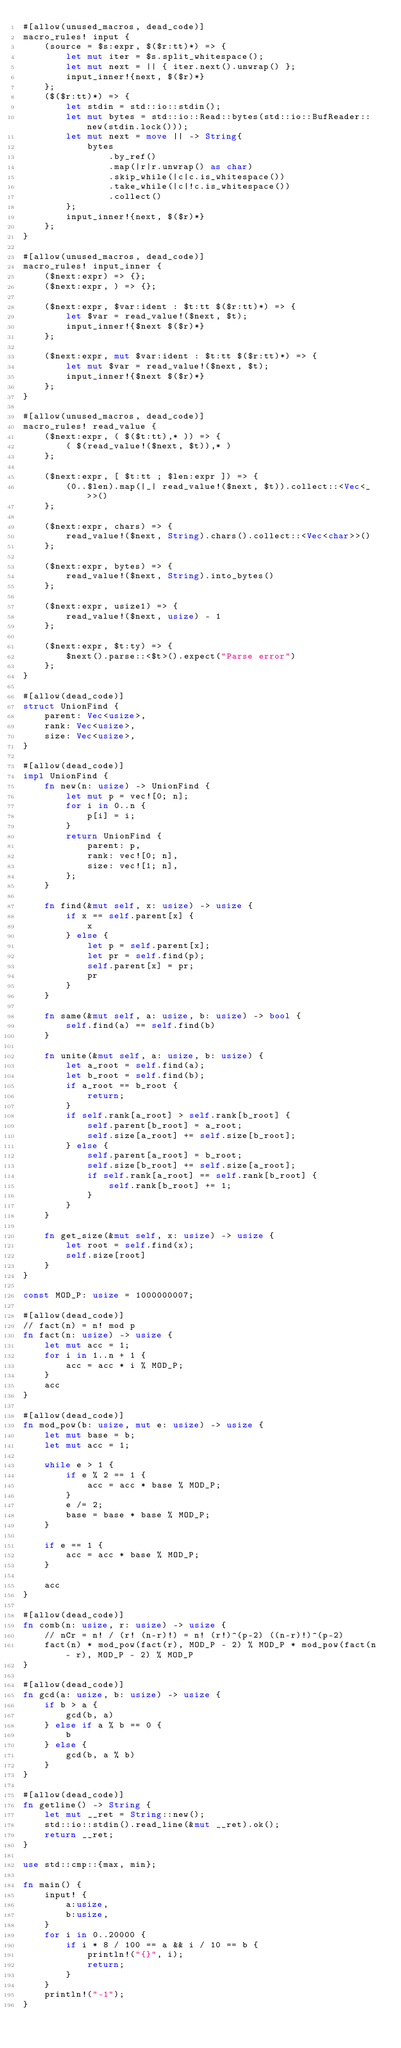Convert code to text. <code><loc_0><loc_0><loc_500><loc_500><_Rust_>#[allow(unused_macros, dead_code)]
macro_rules! input {
    (source = $s:expr, $($r:tt)*) => {
        let mut iter = $s.split_whitespace();
        let mut next = || { iter.next().unwrap() };
        input_inner!{next, $($r)*}
    };
    ($($r:tt)*) => {
        let stdin = std::io::stdin();
        let mut bytes = std::io::Read::bytes(std::io::BufReader::new(stdin.lock()));
        let mut next = move || -> String{
            bytes
                .by_ref()
                .map(|r|r.unwrap() as char)
                .skip_while(|c|c.is_whitespace())
                .take_while(|c|!c.is_whitespace())
                .collect()
        };
        input_inner!{next, $($r)*}
    };
}

#[allow(unused_macros, dead_code)]
macro_rules! input_inner {
    ($next:expr) => {};
    ($next:expr, ) => {};

    ($next:expr, $var:ident : $t:tt $($r:tt)*) => {
        let $var = read_value!($next, $t);
        input_inner!{$next $($r)*}
    };

    ($next:expr, mut $var:ident : $t:tt $($r:tt)*) => {
        let mut $var = read_value!($next, $t);
        input_inner!{$next $($r)*}
    };
}

#[allow(unused_macros, dead_code)]
macro_rules! read_value {
    ($next:expr, ( $($t:tt),* )) => {
        ( $(read_value!($next, $t)),* )
    };

    ($next:expr, [ $t:tt ; $len:expr ]) => {
        (0..$len).map(|_| read_value!($next, $t)).collect::<Vec<_>>()
    };

    ($next:expr, chars) => {
        read_value!($next, String).chars().collect::<Vec<char>>()
    };

    ($next:expr, bytes) => {
        read_value!($next, String).into_bytes()
    };

    ($next:expr, usize1) => {
        read_value!($next, usize) - 1
    };

    ($next:expr, $t:ty) => {
        $next().parse::<$t>().expect("Parse error")
    };
}

#[allow(dead_code)]
struct UnionFind {
    parent: Vec<usize>,
    rank: Vec<usize>,
    size: Vec<usize>,
}

#[allow(dead_code)]
impl UnionFind {
    fn new(n: usize) -> UnionFind {
        let mut p = vec![0; n];
        for i in 0..n {
            p[i] = i;
        }
        return UnionFind {
            parent: p,
            rank: vec![0; n],
            size: vec![1; n],
        };
    }

    fn find(&mut self, x: usize) -> usize {
        if x == self.parent[x] {
            x
        } else {
            let p = self.parent[x];
            let pr = self.find(p);
            self.parent[x] = pr;
            pr
        }
    }

    fn same(&mut self, a: usize, b: usize) -> bool {
        self.find(a) == self.find(b)
    }

    fn unite(&mut self, a: usize, b: usize) {
        let a_root = self.find(a);
        let b_root = self.find(b);
        if a_root == b_root {
            return;
        }
        if self.rank[a_root] > self.rank[b_root] {
            self.parent[b_root] = a_root;
            self.size[a_root] += self.size[b_root];
        } else {
            self.parent[a_root] = b_root;
            self.size[b_root] += self.size[a_root];
            if self.rank[a_root] == self.rank[b_root] {
                self.rank[b_root] += 1;
            }
        }
    }

    fn get_size(&mut self, x: usize) -> usize {
        let root = self.find(x);
        self.size[root]
    }
}

const MOD_P: usize = 1000000007;

#[allow(dead_code)]
// fact(n) = n! mod p
fn fact(n: usize) -> usize {
    let mut acc = 1;
    for i in 1..n + 1 {
        acc = acc * i % MOD_P;
    }
    acc
}

#[allow(dead_code)]
fn mod_pow(b: usize, mut e: usize) -> usize {
    let mut base = b;
    let mut acc = 1;

    while e > 1 {
        if e % 2 == 1 {
            acc = acc * base % MOD_P;
        }
        e /= 2;
        base = base * base % MOD_P;
    }

    if e == 1 {
        acc = acc * base % MOD_P;
    }

    acc
}

#[allow(dead_code)]
fn comb(n: usize, r: usize) -> usize {
    // nCr = n! / (r! (n-r)!) = n! (r!)^(p-2) ((n-r)!)^(p-2)
    fact(n) * mod_pow(fact(r), MOD_P - 2) % MOD_P * mod_pow(fact(n - r), MOD_P - 2) % MOD_P
}

#[allow(dead_code)]
fn gcd(a: usize, b: usize) -> usize {
    if b > a {
        gcd(b, a)
    } else if a % b == 0 {
        b
    } else {
        gcd(b, a % b)
    }
}

#[allow(dead_code)]
fn getline() -> String {
    let mut __ret = String::new();
    std::io::stdin().read_line(&mut __ret).ok();
    return __ret;
}

use std::cmp::{max, min};

fn main() {
    input! {
        a:usize,
        b:usize,
    }
    for i in 0..20000 {
        if i * 8 / 100 == a && i / 10 == b {
            println!("{}", i);
            return;
        }
    }
    println!("-1");
}
</code> 